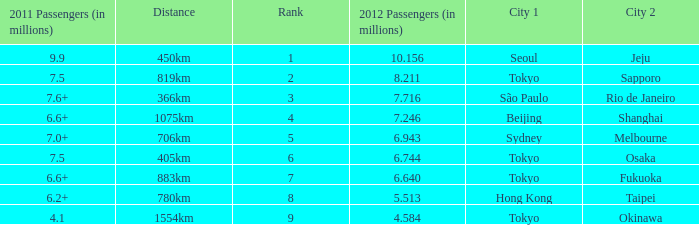How many passengers (in millions) in 2011 flew through along the route that had 6.640 million passengers in 2012? 6.6+. 